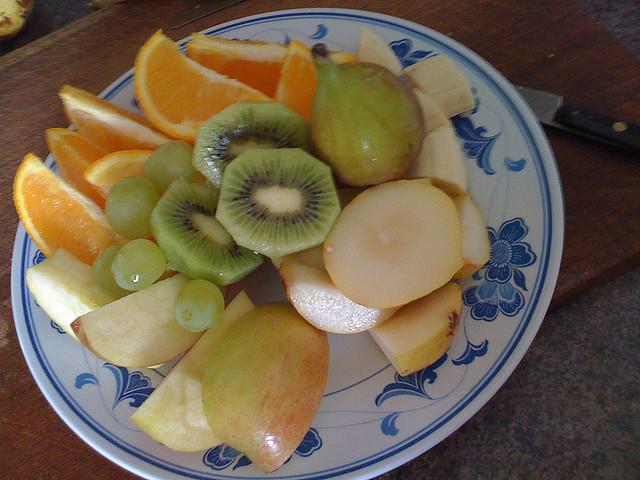Would a vegan eat this meal?
Quick response, please. Yes. What are the green fruit?
Give a very brief answer. Kiwi. What types of fruit are in the picture?
Write a very short answer. Kiwi. Are the having cauliflower with this platter?
Short answer required. No. What type of orange is in the picture?
Concise answer only. Navel. Is the meal vegan?
Concise answer only. Yes. How many types of fruit are in this photo?
Write a very short answer. 6. Is this fruit cut?
Give a very brief answer. Yes. How can you tell someone was trying to attract butterflies?
Short answer required. Fruit. Has the fruit been cut up?
Be succinct. Yes. What fruit is this?
Keep it brief. Orange, apple, grape, kiwi. What are the two fruits on this plate?
Concise answer only. Apples and oranges. Do you see seeds in the fruits?
Quick response, please. Yes. How many seeds can you see?
Short answer required. 0. Are these cooked?
Short answer required. No. Is this plate of food healthy?
Write a very short answer. Yes. How many banana slices are there?
Quick response, please. 4. Do any of the fruits shown have pits?
Give a very brief answer. Yes. What color is this fruit?
Short answer required. Green, orange and white. What is the color of the plate?
Quick response, please. White and blue. What type of fruit is here?
Be succinct. Apple, kiwi, oranges. How many slices is the orange cut into?
Write a very short answer. 8. What color from the rainbow is missing from the cut veggies?
Write a very short answer. Red. Are there avocado slices on the plate?
Concise answer only. No. 